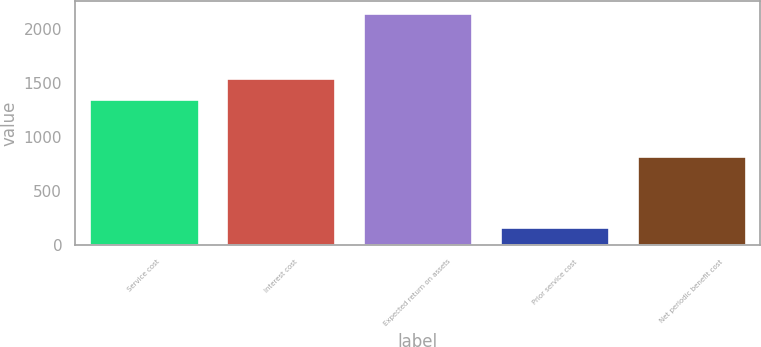Convert chart to OTSL. <chart><loc_0><loc_0><loc_500><loc_500><bar_chart><fcel>Service cost<fcel>Interest cost<fcel>Expected return on assets<fcel>Prior service cost<fcel>Net periodic benefit cost<nl><fcel>1349<fcel>1546.5<fcel>2147<fcel>172<fcel>823<nl></chart> 